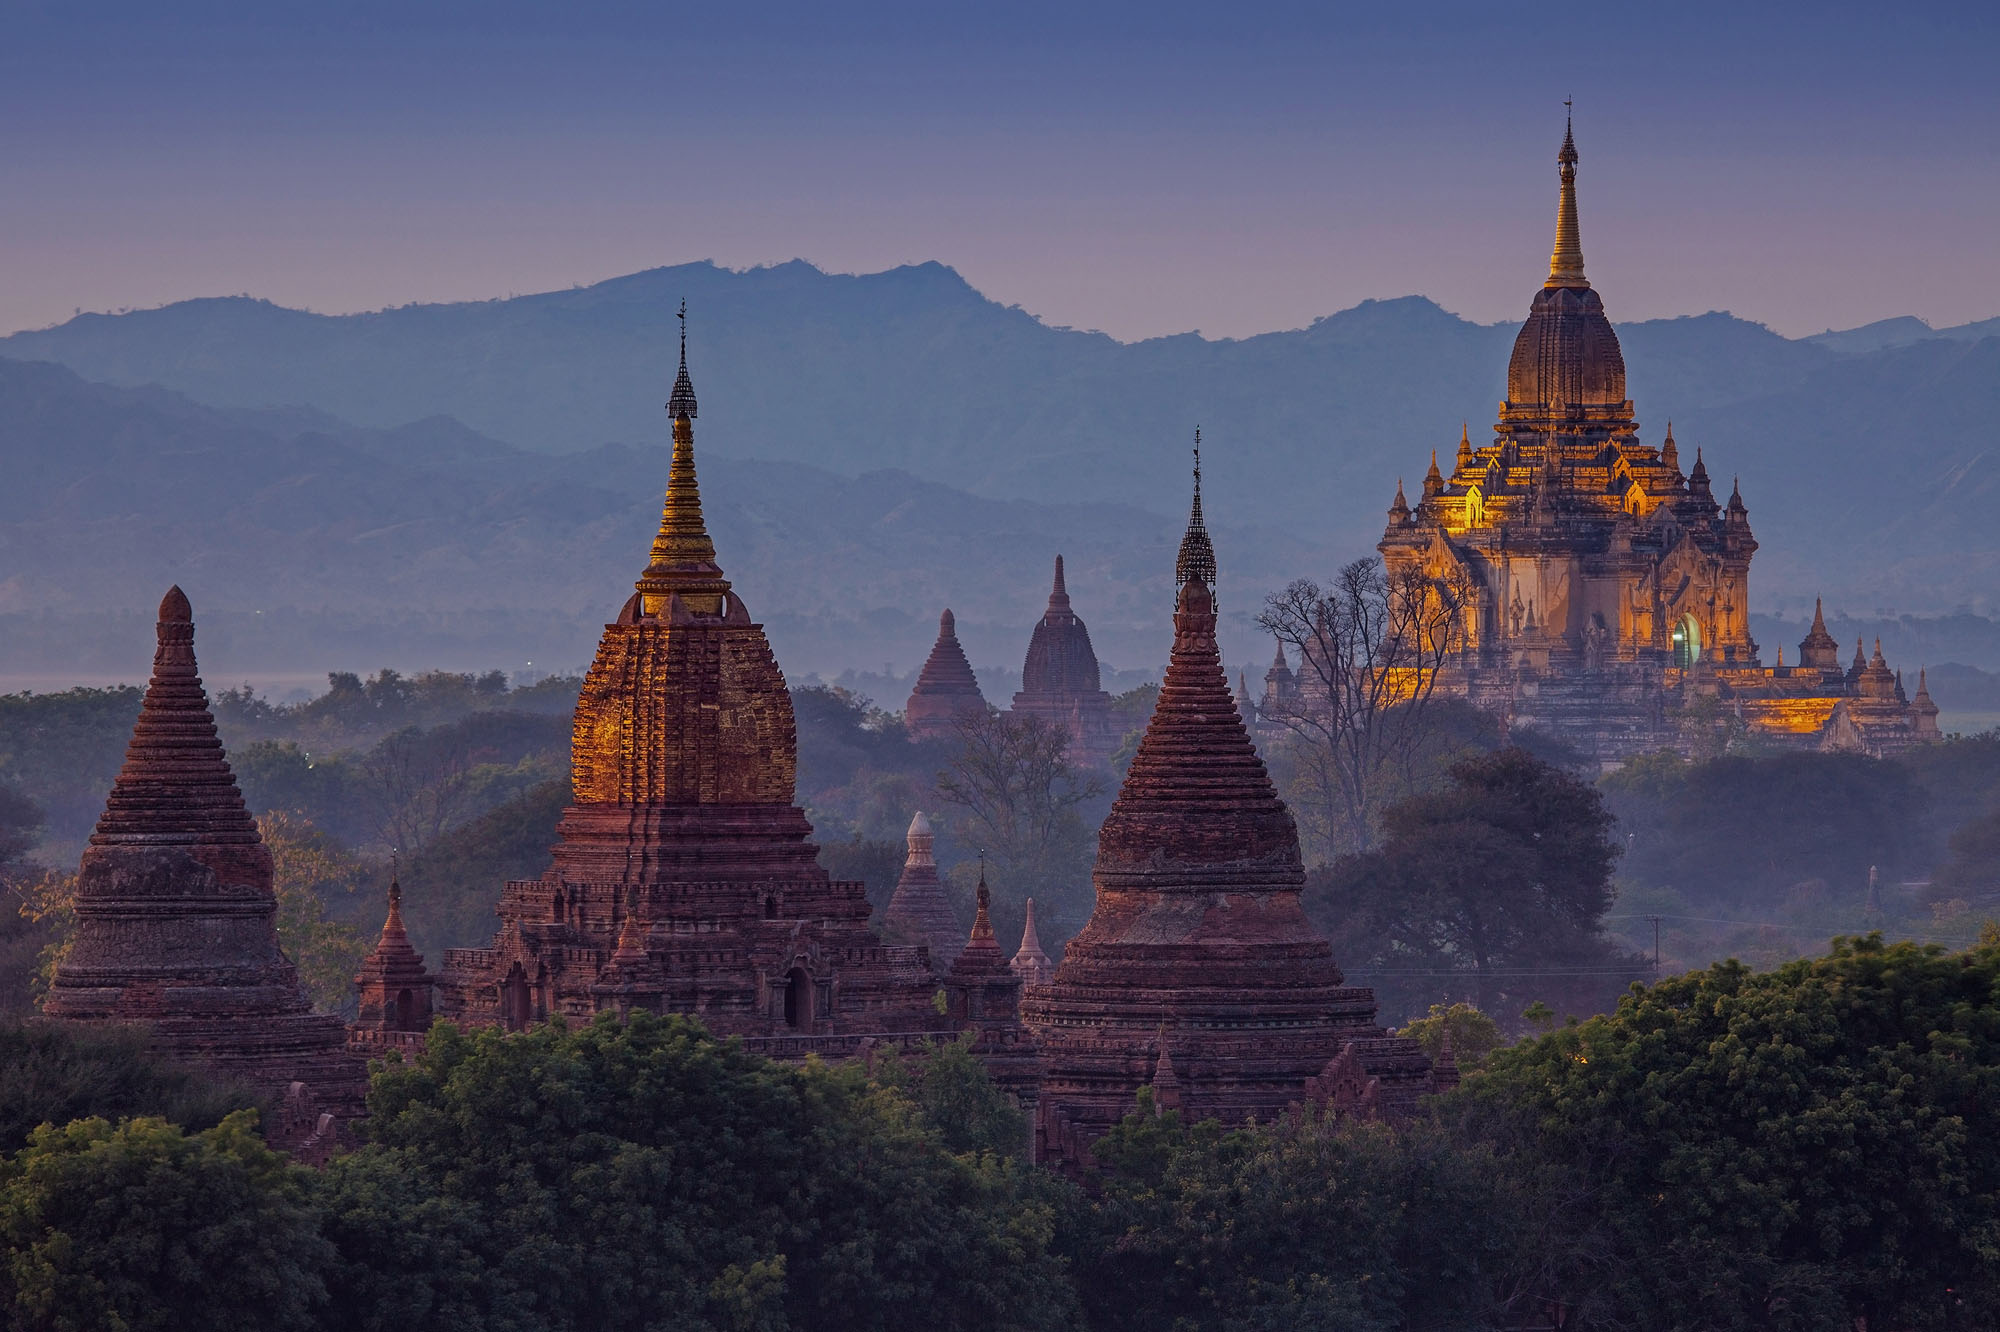Can you tell more about the significance of these temples in Bagan? The temples in Bagan are a testament to the religious dedication of the ancient Kingdom of Pagan. From the 9th to 13th centuries, kings and commoners alike contributed to building these structures, which served not only as places of worship but also as a demonstration of political power and religious devotion. Each temple has unique internal frescoes and statues of Buddha, making them important both spiritually and historically. 